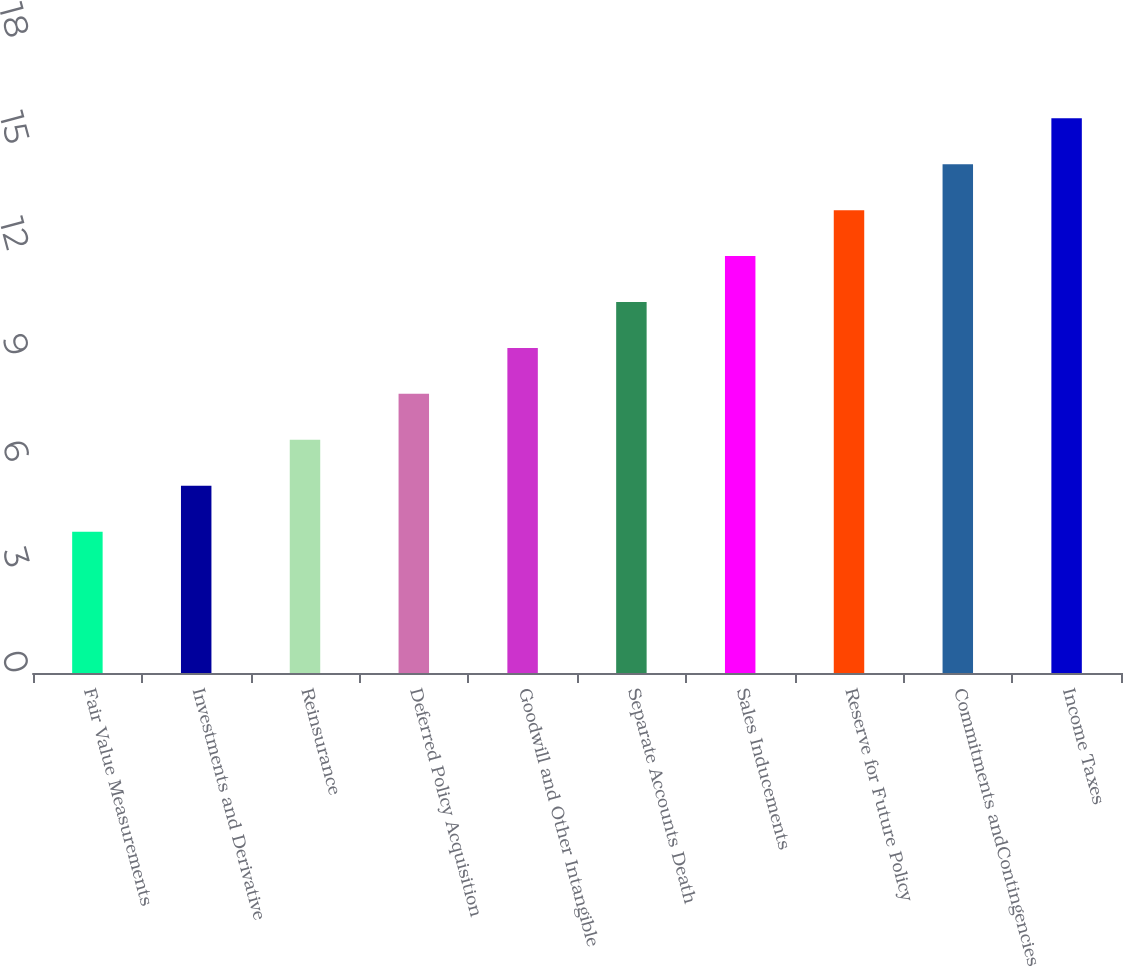<chart> <loc_0><loc_0><loc_500><loc_500><bar_chart><fcel>Fair Value Measurements<fcel>Investments and Derivative<fcel>Reinsurance<fcel>Deferred Policy Acquisition<fcel>Goodwill and Other Intangible<fcel>Separate Accounts Death<fcel>Sales Inducements<fcel>Reserve for Future Policy<fcel>Commitments andContingencies<fcel>Income Taxes<nl><fcel>4<fcel>5.3<fcel>6.6<fcel>7.9<fcel>9.2<fcel>10.5<fcel>11.8<fcel>13.1<fcel>14.4<fcel>15.7<nl></chart> 